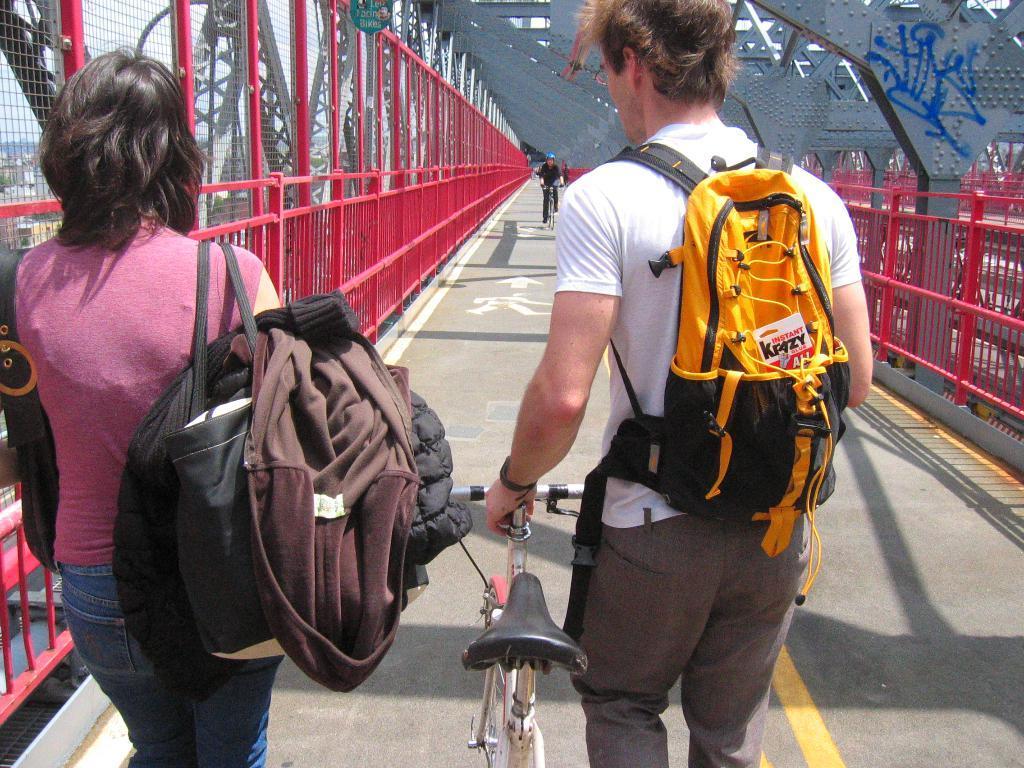In one or two sentences, can you explain what this image depicts? In this image I can see two people are wearing the bags and one person is holding the bicycle and there are to the side of the railing. In the background one person is riding the bicycle. 